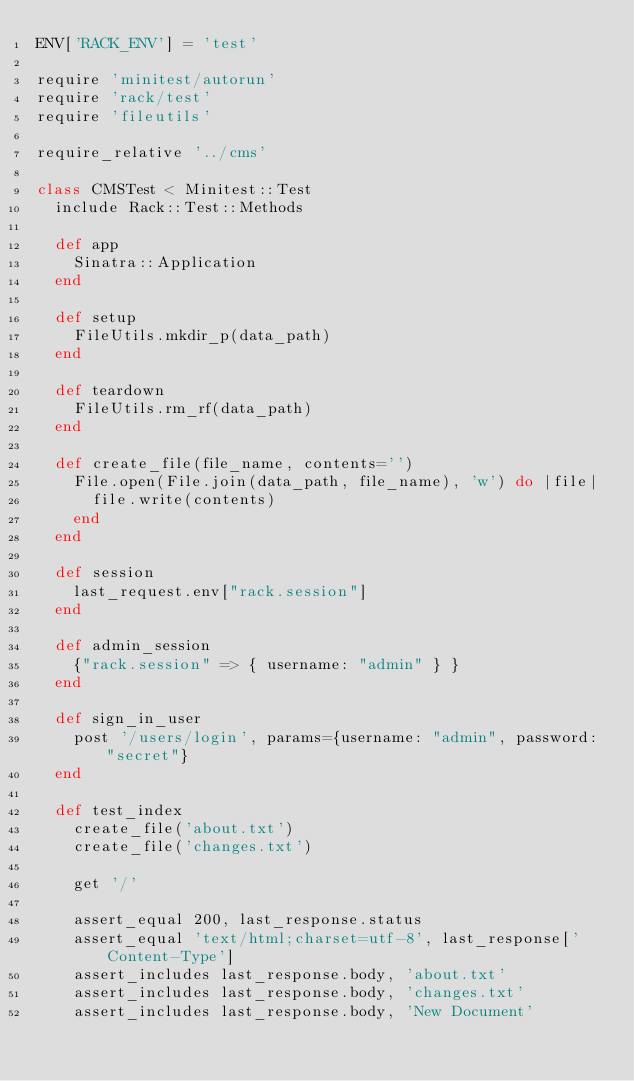Convert code to text. <code><loc_0><loc_0><loc_500><loc_500><_Ruby_>ENV['RACK_ENV'] = 'test'

require 'minitest/autorun'
require 'rack/test'
require 'fileutils'

require_relative '../cms'

class CMSTest < Minitest::Test
  include Rack::Test::Methods

  def app
    Sinatra::Application
  end

  def setup
    FileUtils.mkdir_p(data_path)
  end

  def teardown
    FileUtils.rm_rf(data_path)
  end

  def create_file(file_name, contents='')
    File.open(File.join(data_path, file_name), 'w') do |file|
      file.write(contents)
    end
  end

  def session
    last_request.env["rack.session"]
  end

  def admin_session
    {"rack.session" => { username: "admin" } }
  end

  def sign_in_user
    post '/users/login', params={username: "admin", password: "secret"}
  end

  def test_index
    create_file('about.txt')
    create_file('changes.txt')

    get '/'

    assert_equal 200, last_response.status
    assert_equal 'text/html;charset=utf-8', last_response['Content-Type']
    assert_includes last_response.body, 'about.txt'
    assert_includes last_response.body, 'changes.txt'
    assert_includes last_response.body, 'New Document'</code> 